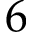Convert formula to latex. <formula><loc_0><loc_0><loc_500><loc_500>6</formula> 